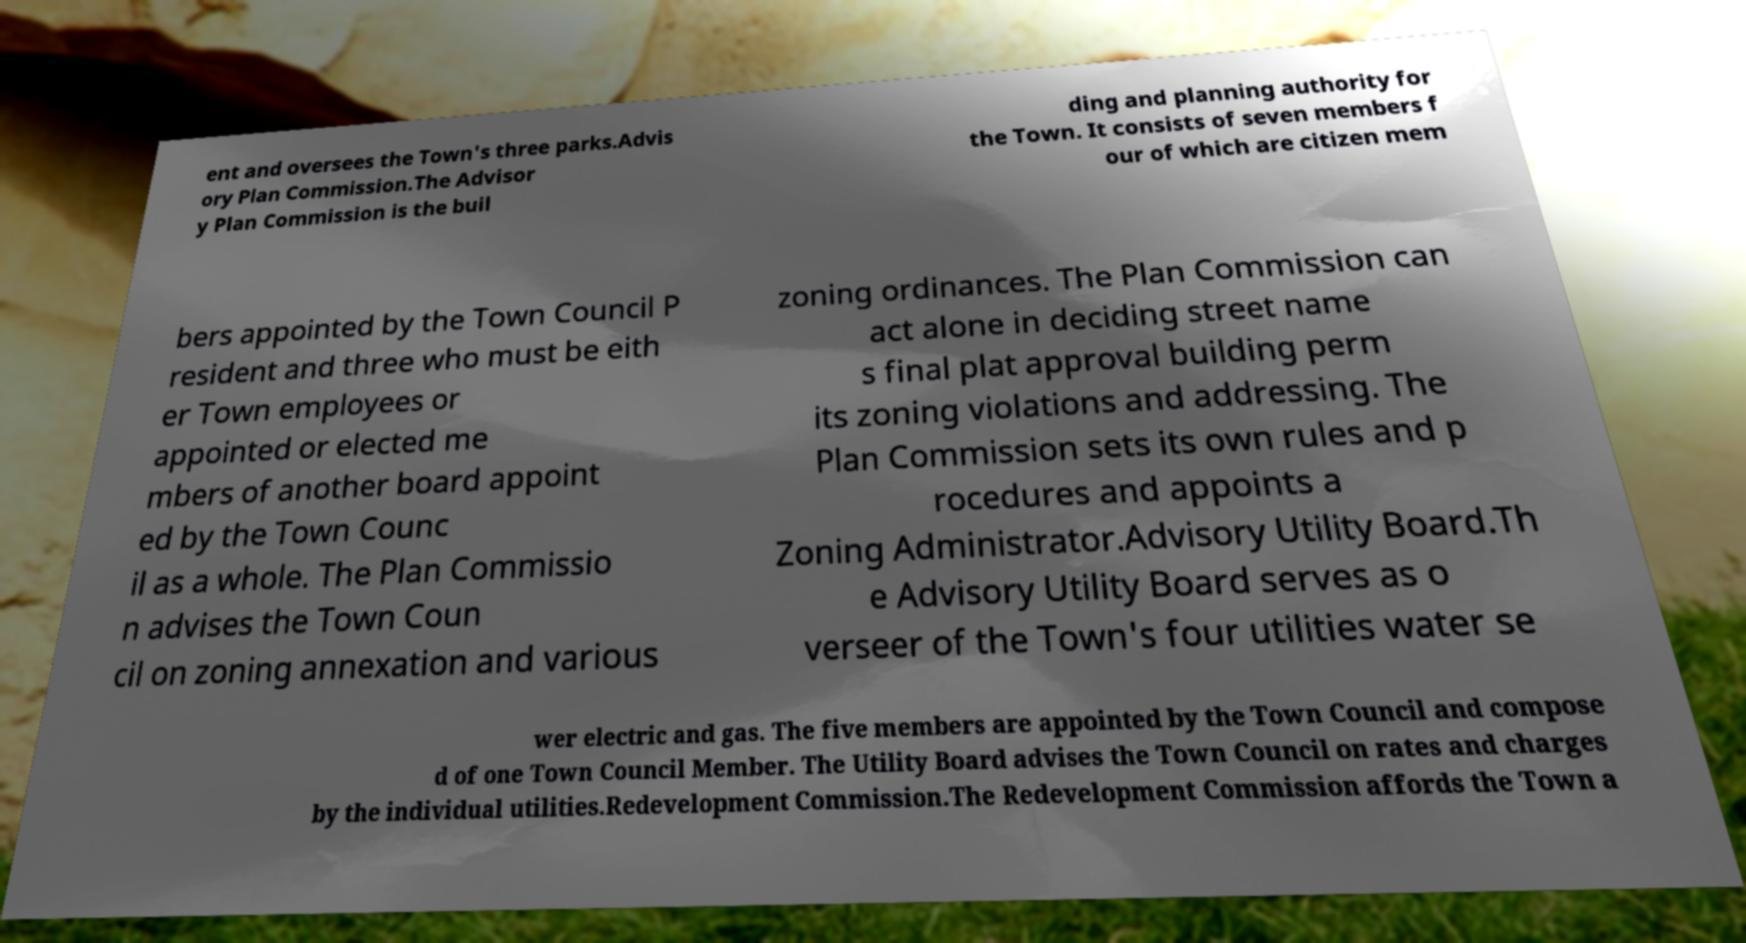I need the written content from this picture converted into text. Can you do that? ent and oversees the Town's three parks.Advis ory Plan Commission.The Advisor y Plan Commission is the buil ding and planning authority for the Town. It consists of seven members f our of which are citizen mem bers appointed by the Town Council P resident and three who must be eith er Town employees or appointed or elected me mbers of another board appoint ed by the Town Counc il as a whole. The Plan Commissio n advises the Town Coun cil on zoning annexation and various zoning ordinances. The Plan Commission can act alone in deciding street name s final plat approval building perm its zoning violations and addressing. The Plan Commission sets its own rules and p rocedures and appoints a Zoning Administrator.Advisory Utility Board.Th e Advisory Utility Board serves as o verseer of the Town's four utilities water se wer electric and gas. The five members are appointed by the Town Council and compose d of one Town Council Member. The Utility Board advises the Town Council on rates and charges by the individual utilities.Redevelopment Commission.The Redevelopment Commission affords the Town a 